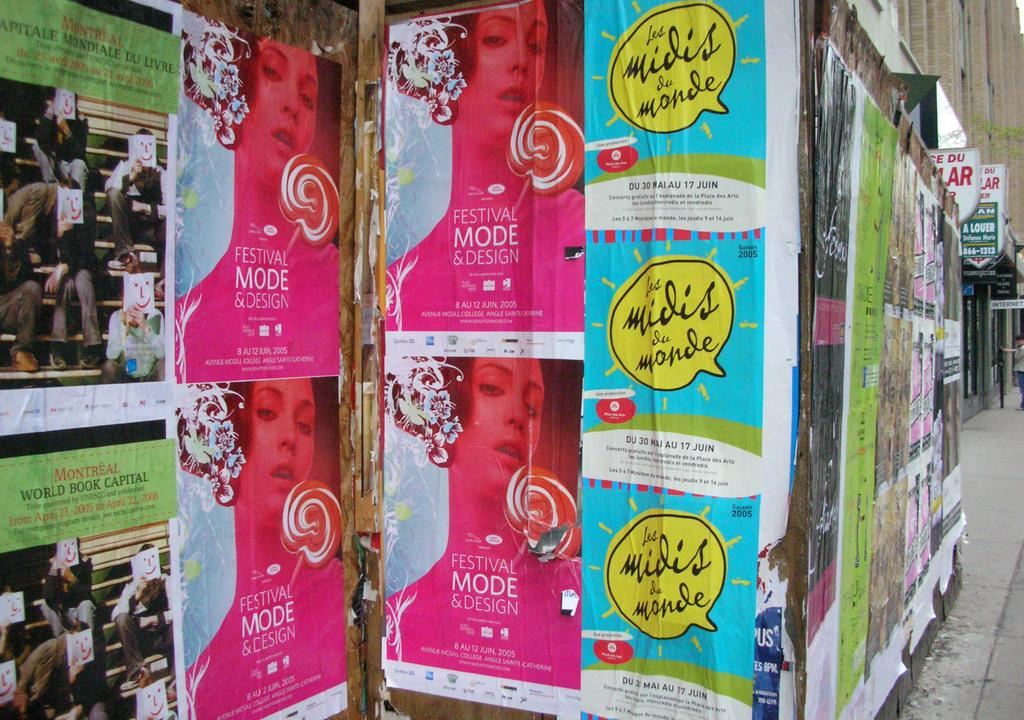<image>
Give a short and clear explanation of the subsequent image. a wall of posters with one that says 'festival mode & design' 